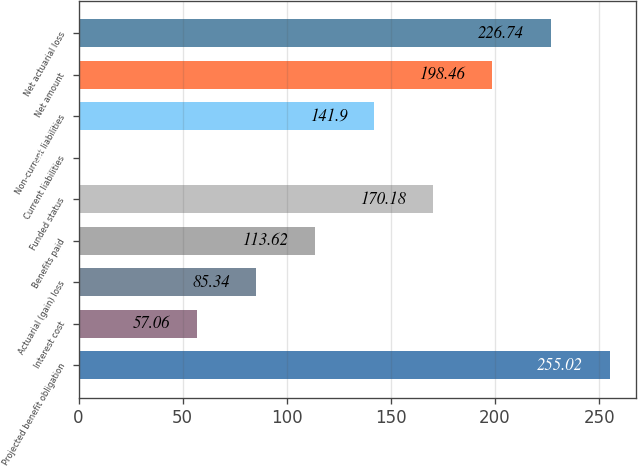Convert chart to OTSL. <chart><loc_0><loc_0><loc_500><loc_500><bar_chart><fcel>Projected benefit obligation<fcel>Interest cost<fcel>Actuarial (gain) loss<fcel>Benefits paid<fcel>Funded status<fcel>Current liabilities<fcel>Non-current liabilities<fcel>Net amount<fcel>Net actuarial loss<nl><fcel>255.02<fcel>57.06<fcel>85.34<fcel>113.62<fcel>170.18<fcel>0.5<fcel>141.9<fcel>198.46<fcel>226.74<nl></chart> 